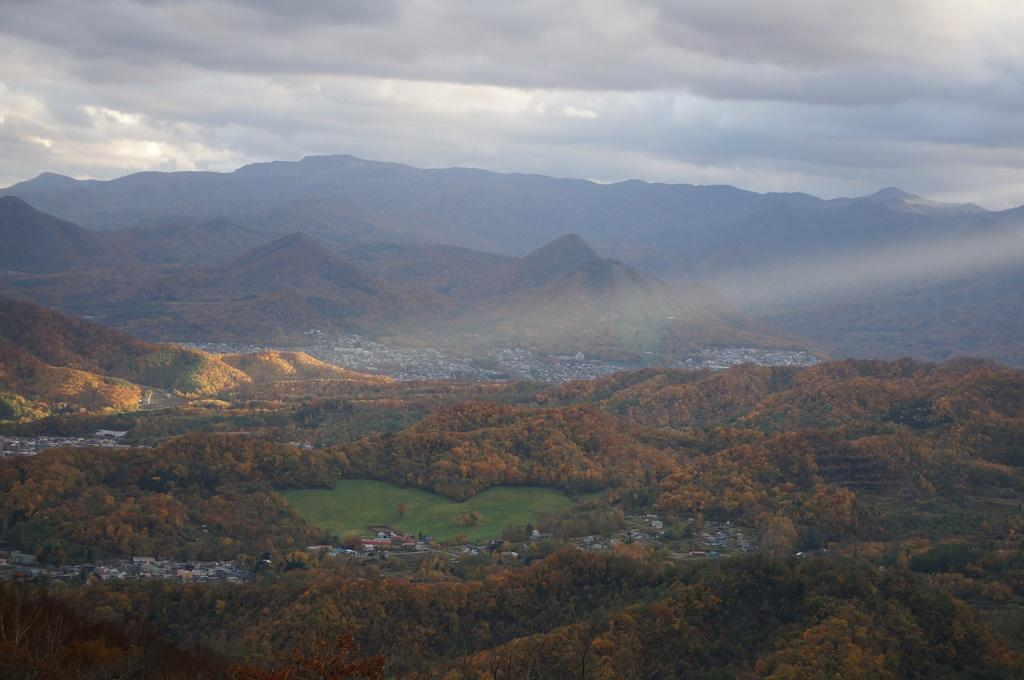What type of natural environment is depicted in the image? There are trees and grass in the image, which suggests a natural setting. How do the trees and grass appear to resemble buildings on the left side? The trees and grass on the left side of the image have a shape or arrangement that resembles buildings. What can be seen in the distance in the image? There are hills visible in the background of the image. What is visible at the top of the image? The sky is visible at the top of the image. What type of ink is used to color the coastline in the image? There is no coastline present in the image, and therefore no ink is used to color it. 